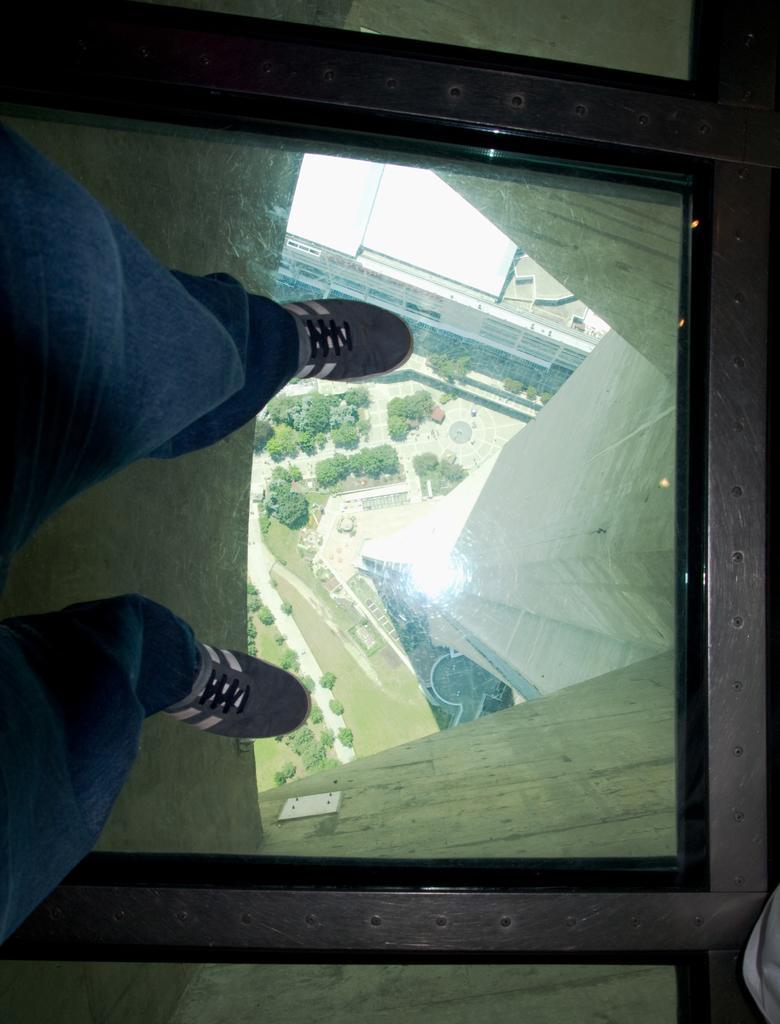Could you give a brief overview of what you see in this image? On the left side of the image we can see a person standing on the glass and we can see trees and a road through the glass. 